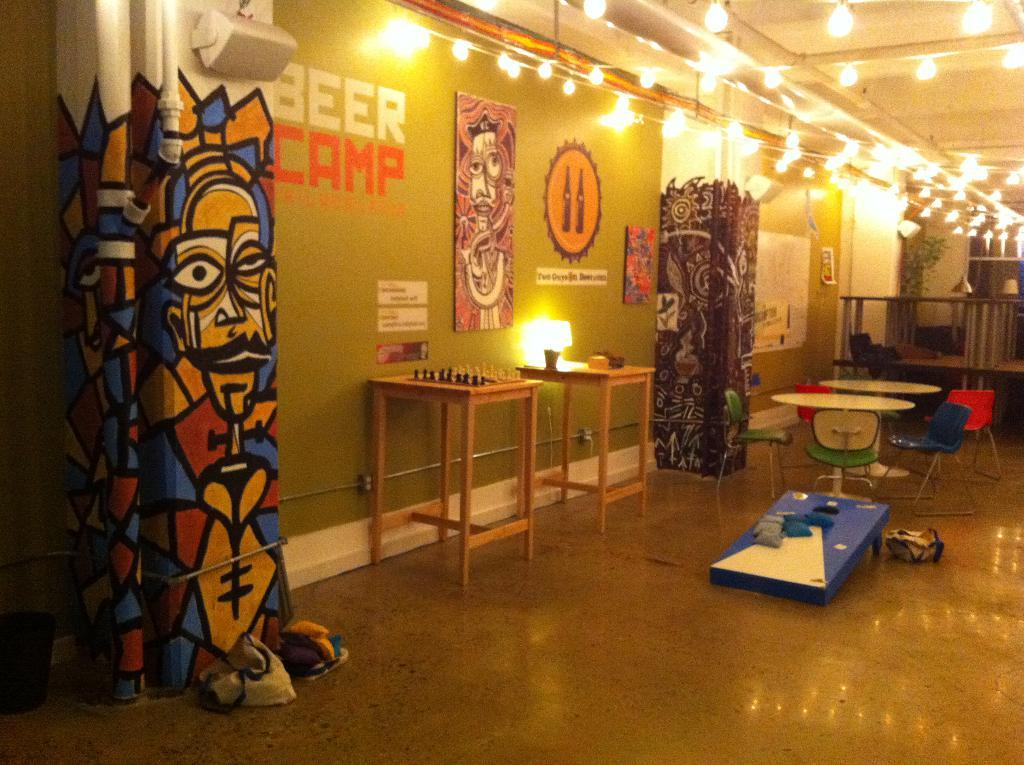<image>
Describe the image concisely. A chess board on a table under text that says BEER CAMP. 